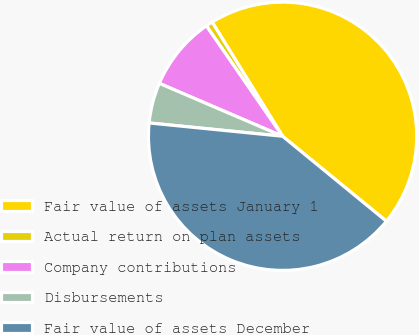Convert chart to OTSL. <chart><loc_0><loc_0><loc_500><loc_500><pie_chart><fcel>Fair value of assets January 1<fcel>Actual return on plan assets<fcel>Company contributions<fcel>Disbursements<fcel>Fair value of assets December<nl><fcel>44.72%<fcel>0.82%<fcel>8.93%<fcel>4.87%<fcel>40.66%<nl></chart> 